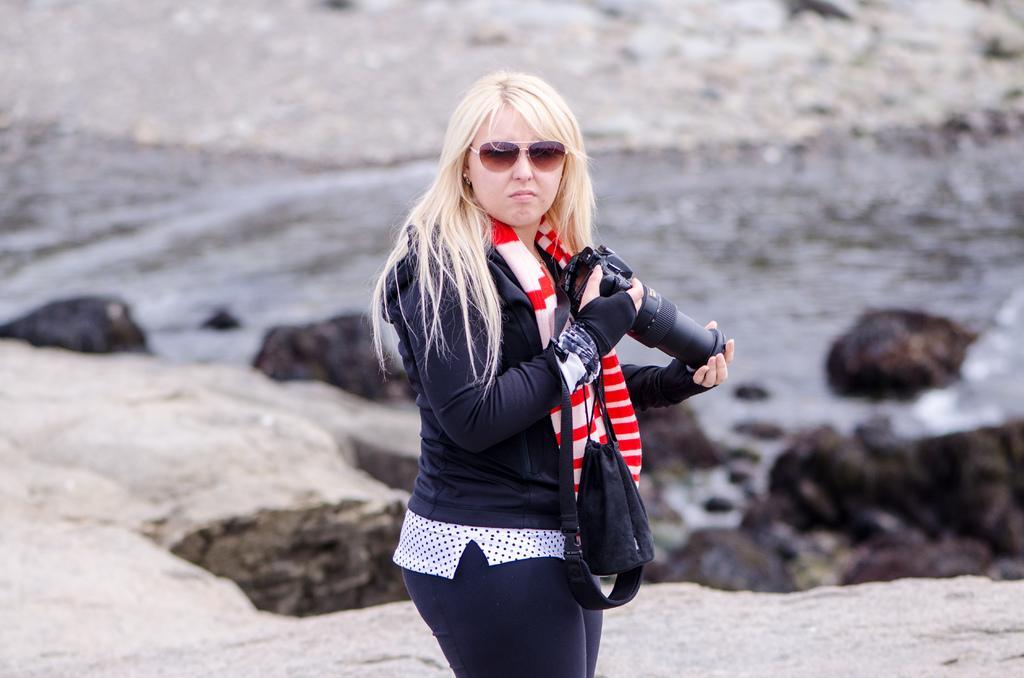In one or two sentences, can you explain what this image depicts? In this image there is a lady standing and holding a camera in her hand, behind her there is a river and rocks. 